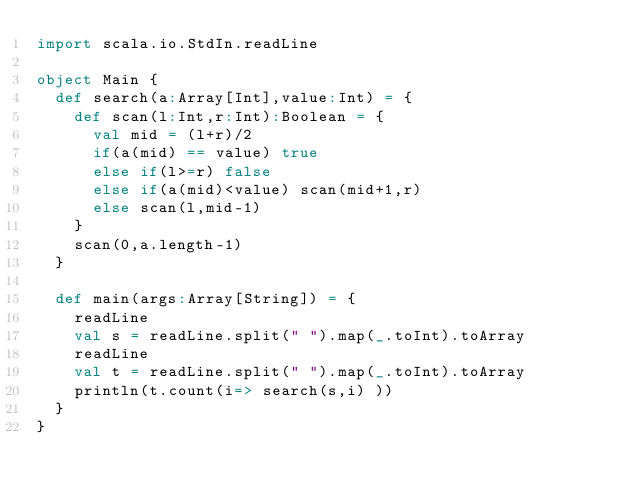Convert code to text. <code><loc_0><loc_0><loc_500><loc_500><_Scala_>import scala.io.StdIn.readLine
 
object Main {
  def search(a:Array[Int],value:Int) = {
    def scan(l:Int,r:Int):Boolean = {
      val mid = (l+r)/2
      if(a(mid) == value) true
      else if(l>=r) false
      else if(a(mid)<value) scan(mid+1,r)
      else scan(l,mid-1)
    }
    scan(0,a.length-1)
  }
 
  def main(args:Array[String]) = {
    readLine
    val s = readLine.split(" ").map(_.toInt).toArray
    readLine
    val t = readLine.split(" ").map(_.toInt).toArray
    println(t.count(i=> search(s,i) ))
  }
}</code> 